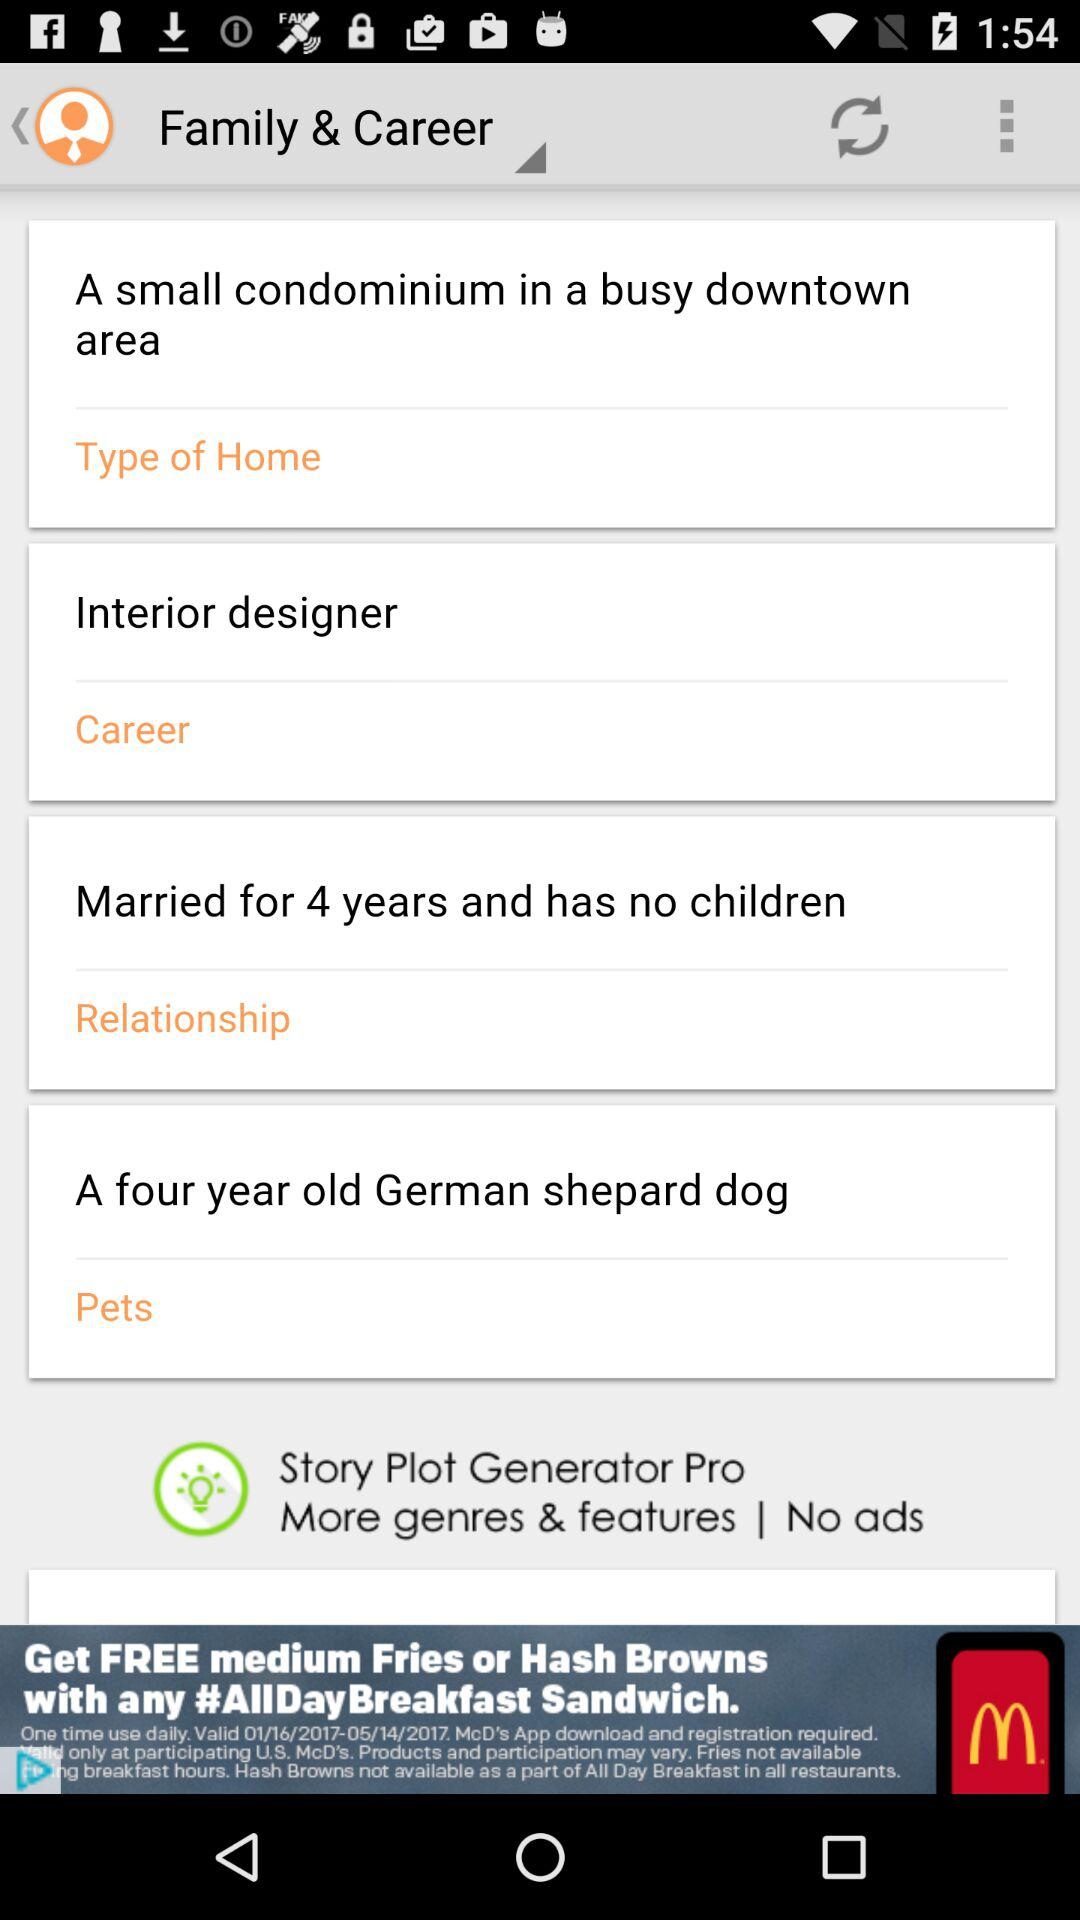How many years of marriage has been completed? The number of completed years is 4. 